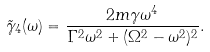<formula> <loc_0><loc_0><loc_500><loc_500>\tilde { \gamma } _ { 4 } ( \omega ) = \frac { 2 m \gamma \omega ^ { 4 } } { \Gamma ^ { 2 } \omega ^ { 2 } + ( \Omega ^ { 2 } - \omega ^ { 2 } ) ^ { 2 } } .</formula> 